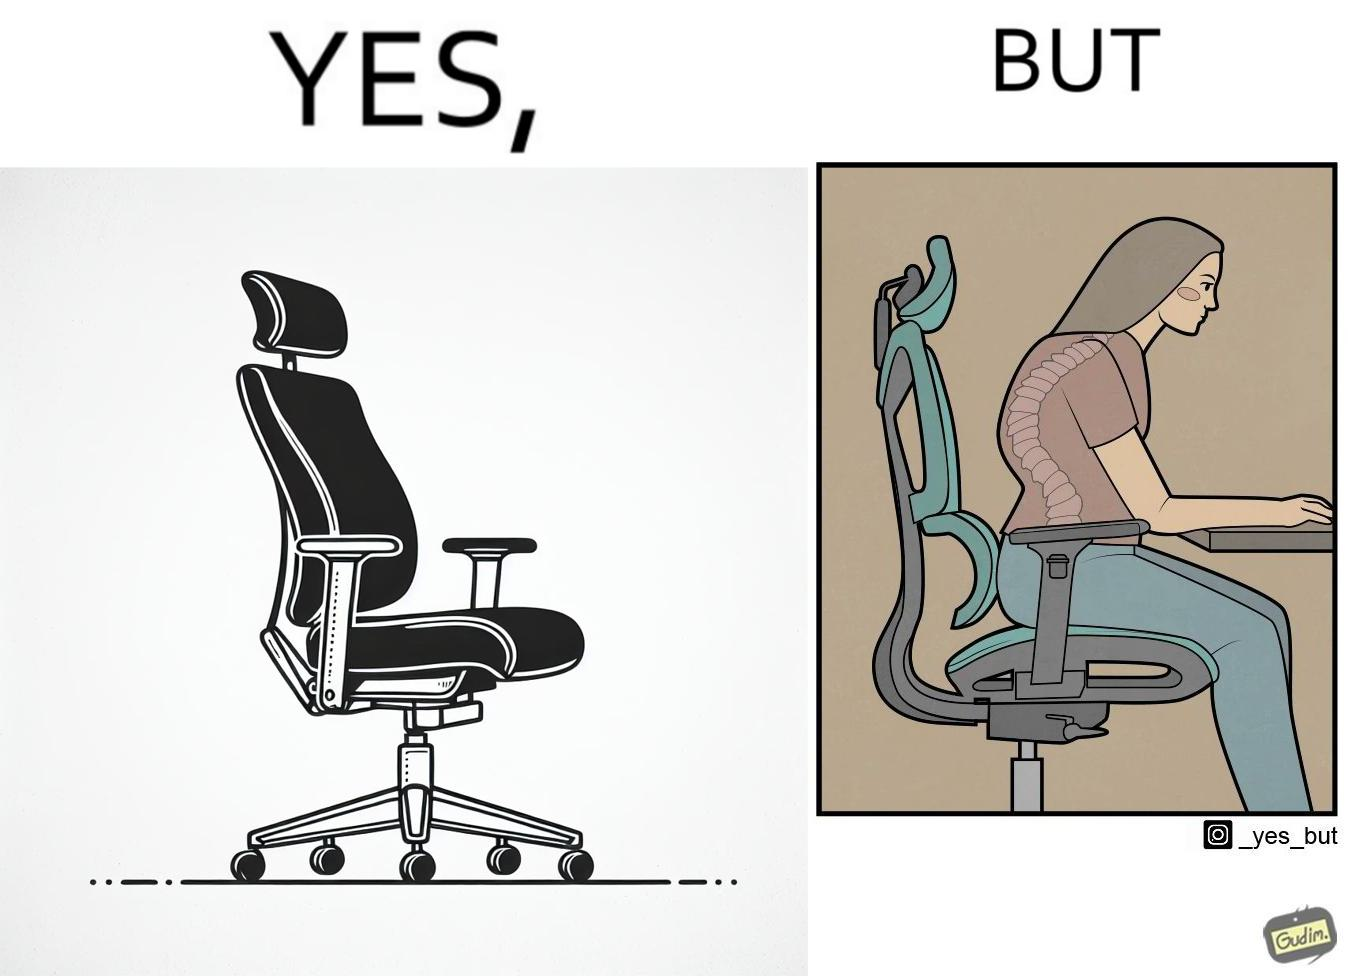What makes this image funny or satirical? The image is ironical, as even though the ergonomic chair is meant to facilitate an upright and comfortable posture for the person sitting on it, the person sitting on it still has a bent posture, as the person is not utilizing the backrest. 